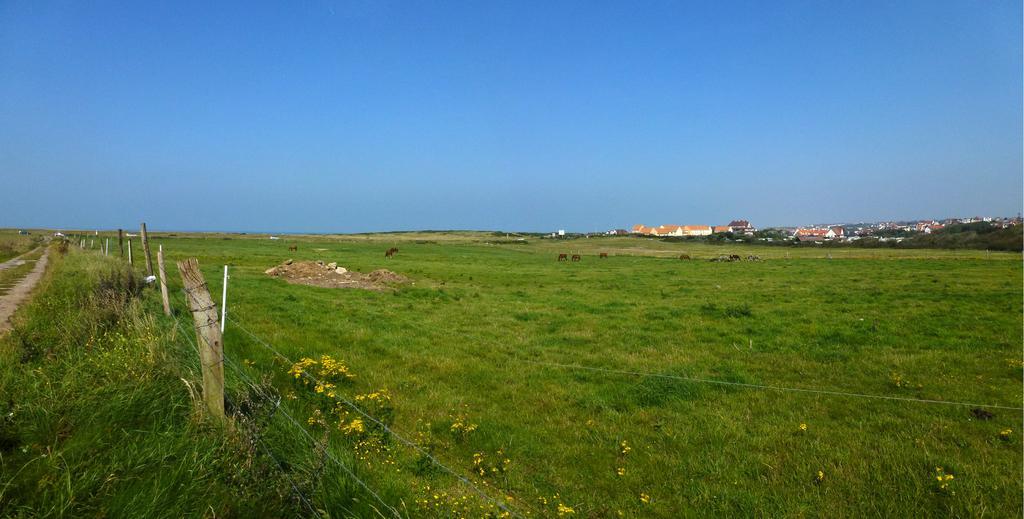In one or two sentences, can you explain what this image depicts? In this picture we can see the grass, fence, stones, flowers, animals, buildings, trees and in the background we can see the sky. 